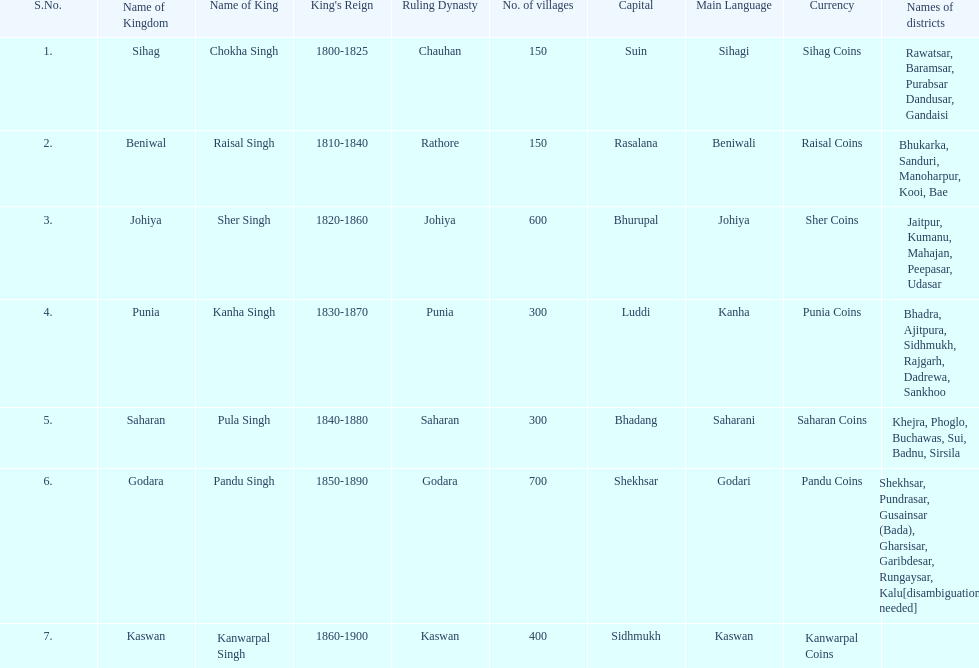What is the next kingdom listed after sihag? Beniwal. 